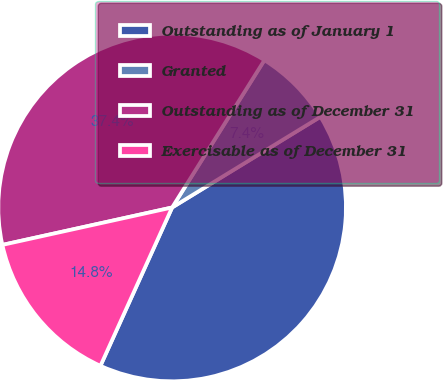<chart> <loc_0><loc_0><loc_500><loc_500><pie_chart><fcel>Outstanding as of January 1<fcel>Granted<fcel>Outstanding as of December 31<fcel>Exercisable as of December 31<nl><fcel>40.5%<fcel>7.36%<fcel>37.36%<fcel>14.78%<nl></chart> 